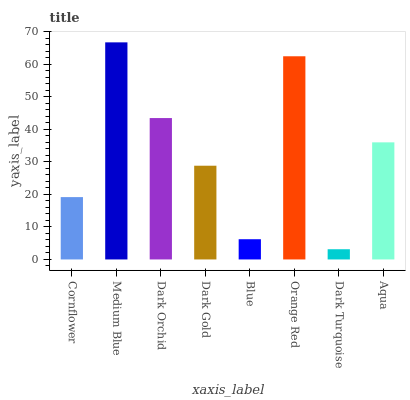Is Dark Turquoise the minimum?
Answer yes or no. Yes. Is Medium Blue the maximum?
Answer yes or no. Yes. Is Dark Orchid the minimum?
Answer yes or no. No. Is Dark Orchid the maximum?
Answer yes or no. No. Is Medium Blue greater than Dark Orchid?
Answer yes or no. Yes. Is Dark Orchid less than Medium Blue?
Answer yes or no. Yes. Is Dark Orchid greater than Medium Blue?
Answer yes or no. No. Is Medium Blue less than Dark Orchid?
Answer yes or no. No. Is Aqua the high median?
Answer yes or no. Yes. Is Dark Gold the low median?
Answer yes or no. Yes. Is Dark Gold the high median?
Answer yes or no. No. Is Dark Turquoise the low median?
Answer yes or no. No. 